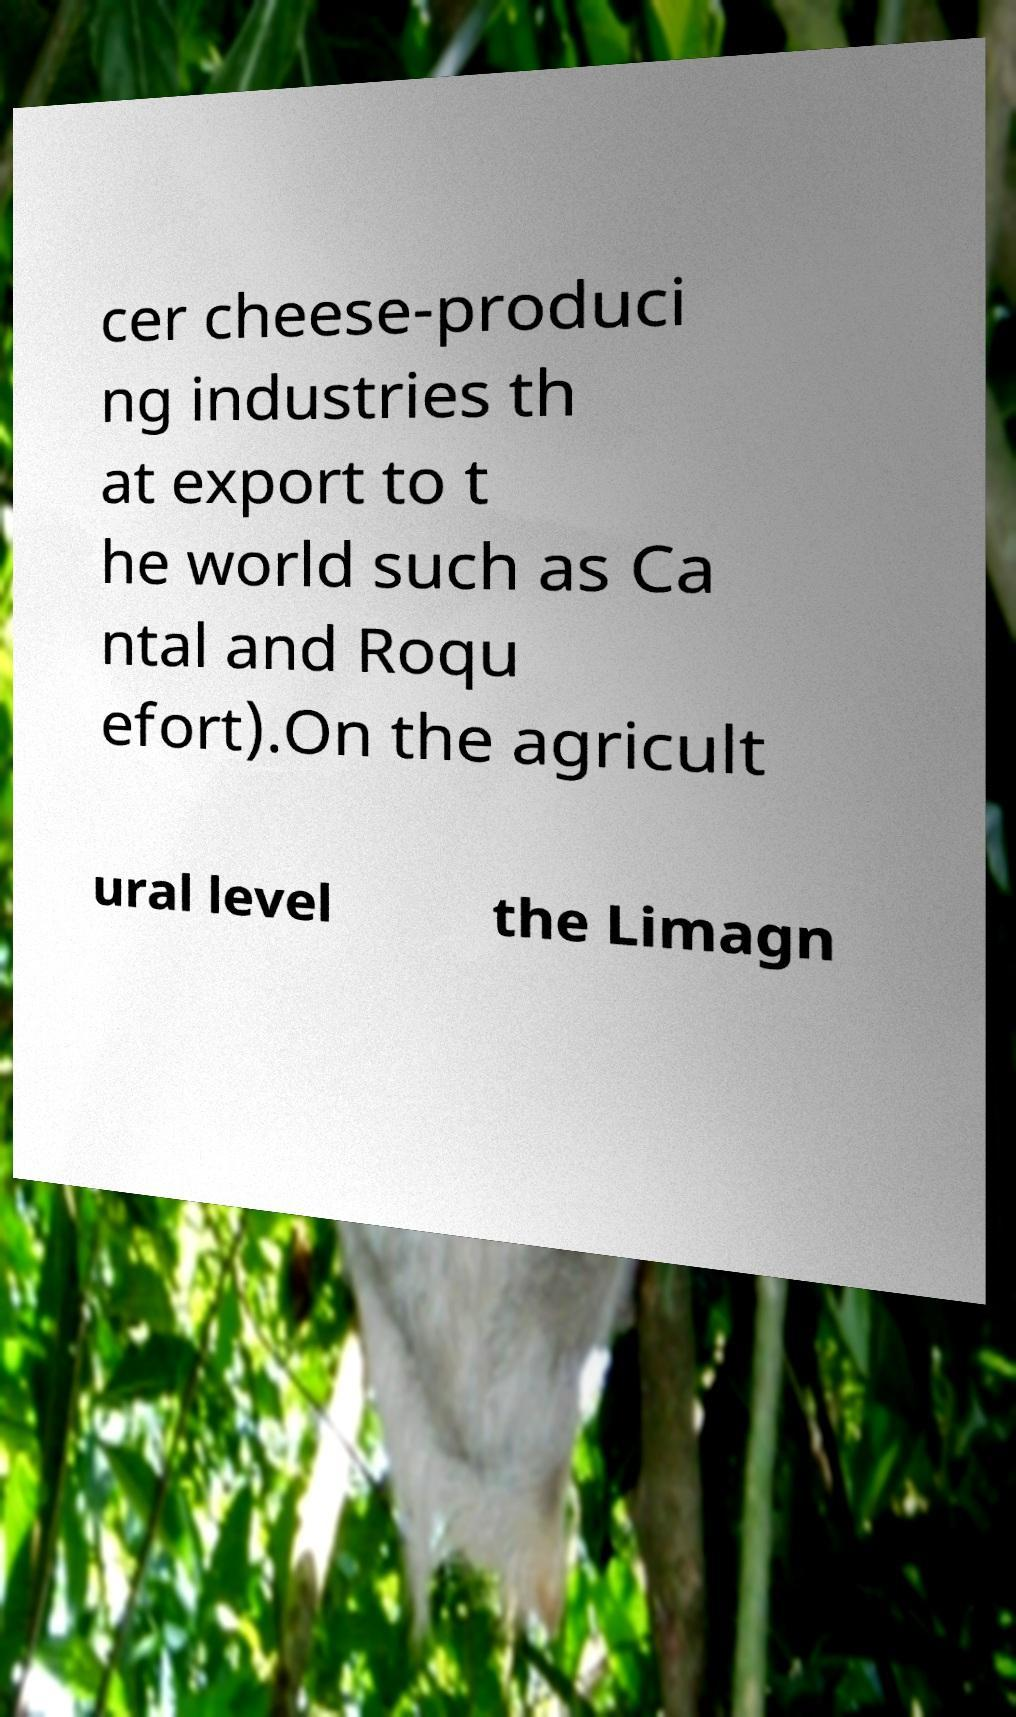There's text embedded in this image that I need extracted. Can you transcribe it verbatim? cer cheese-produci ng industries th at export to t he world such as Ca ntal and Roqu efort).On the agricult ural level the Limagn 